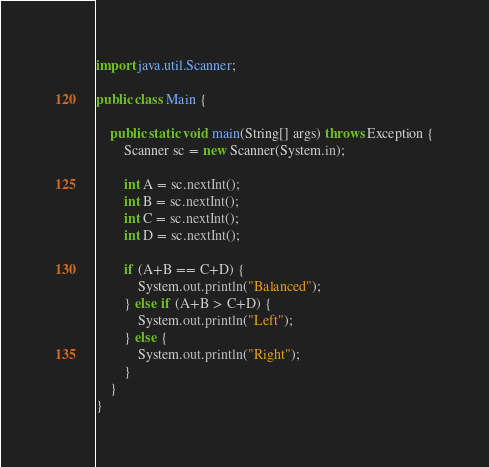Convert code to text. <code><loc_0><loc_0><loc_500><loc_500><_Java_>import java.util.Scanner;

public class Main {
	
	public static void main(String[] args) throws Exception {
	    Scanner sc = new Scanner(System.in);   
	    
	    int A = sc.nextInt();
	    int B = sc.nextInt();
	    int C = sc.nextInt();
	    int D = sc.nextInt();
	    
	    if (A+B == C+D) {
	    	System.out.println("Balanced");
	    } else if (A+B > C+D) {
	    	System.out.println("Left");
	    } else {
	    	System.out.println("Right");
	    }
	}    
}	</code> 